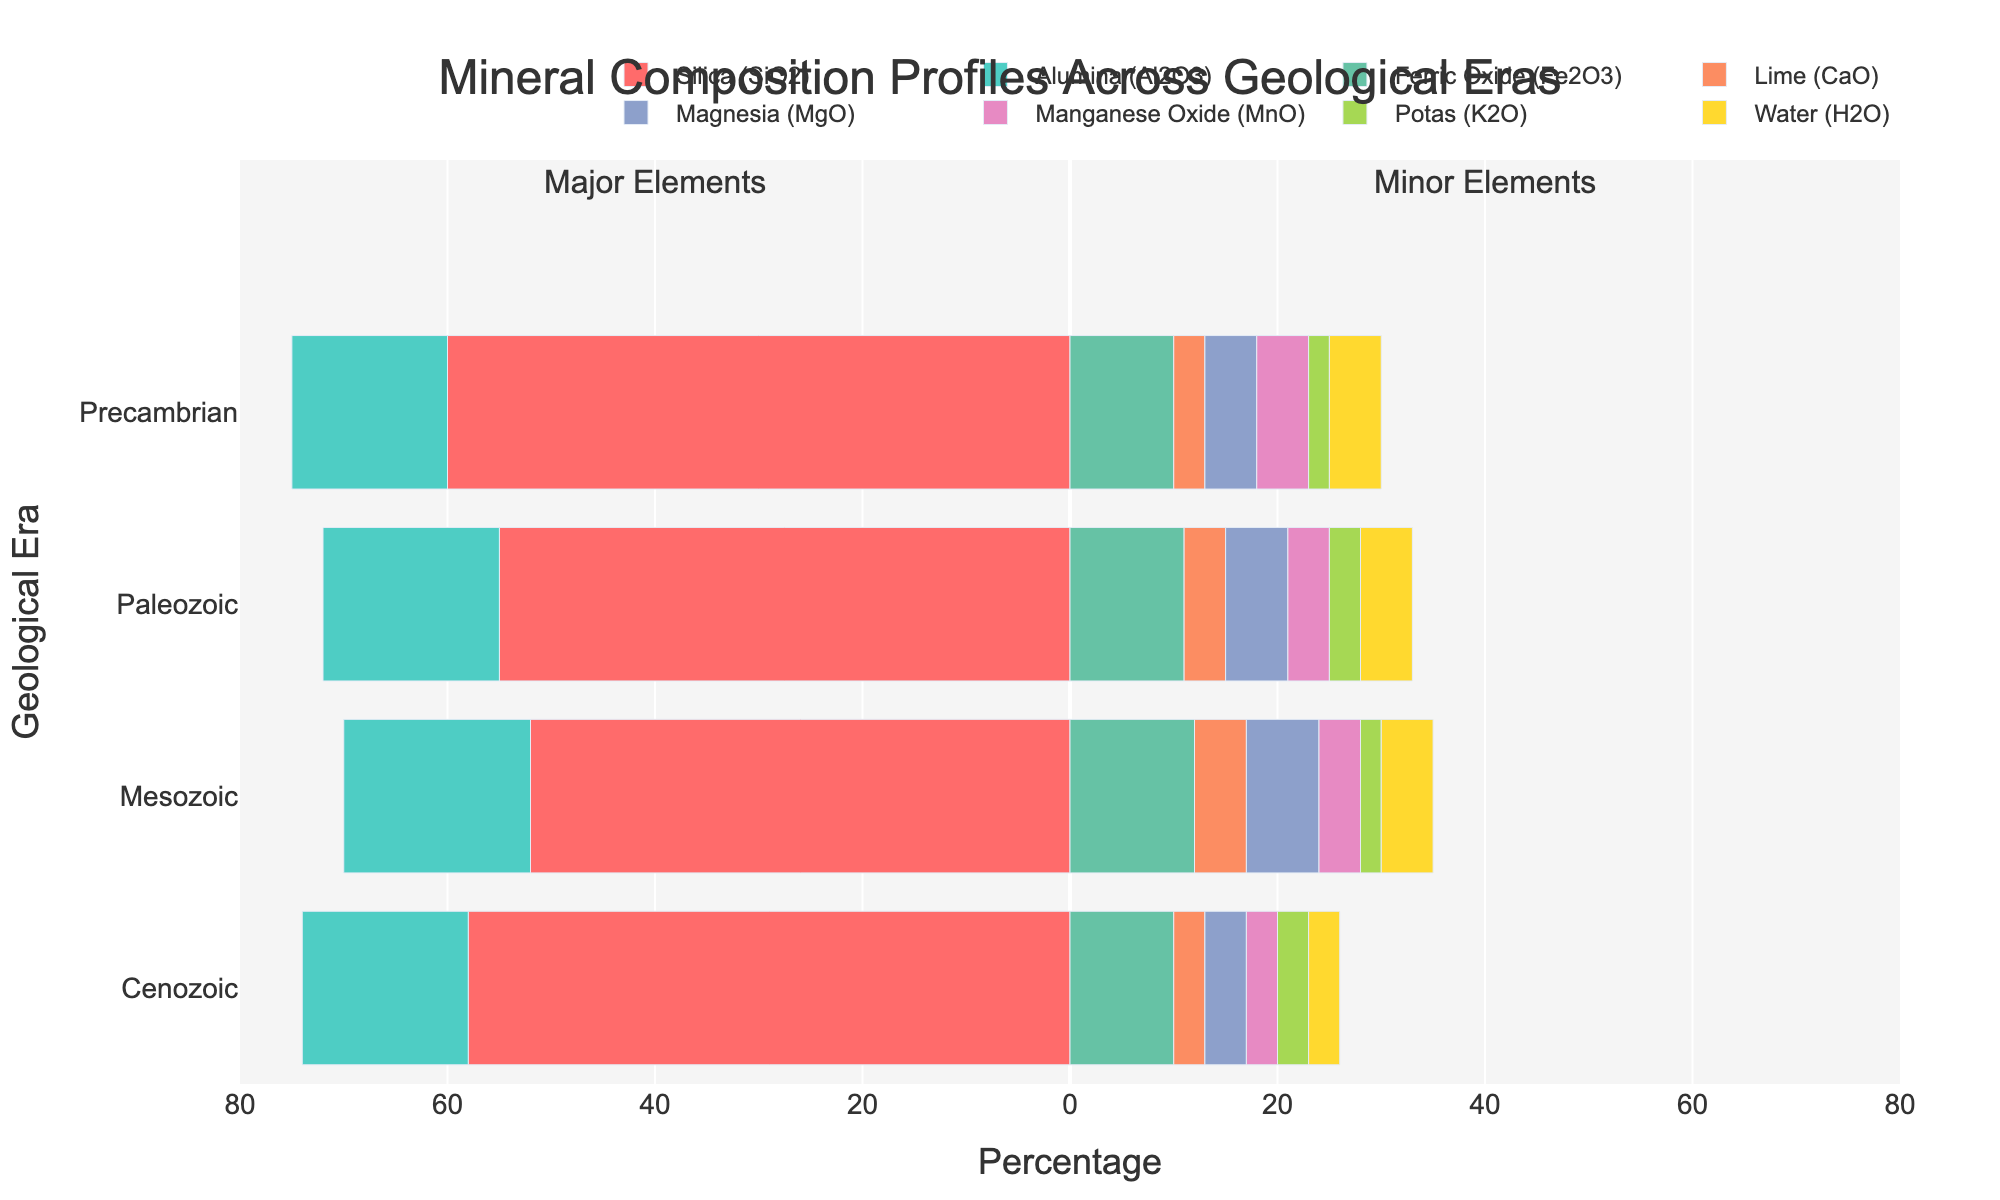What is the total percentage of major elements in the Precambrian era? To find the total percentage of major elements in the Precambrian era, sum the percentages of Silica (SiO2) and Alumina (Al2O3): 60 + 15 = 75
Answer: 75 Which era has the highest percentage of Silica (SiO2)? Compare the percentages of Silica (SiO2) across all eras: Precambrian (60%), Paleozoic (55%), Mesozoic (52%), Cenozoic (58%). The highest is in the Precambrian.
Answer: Precambrian How does the percentage of Ferric Oxide (Fe2O3) in the Paleozoic era compare to the Mesozoic era? The percentage of Ferric Oxide in the Paleozoic era is 11% and in the Mesozoic era is 12%. 11% is less than 12%.
Answer: Less than What is the sum of minor elements in the Cenozoic era? Sum the percentages of all minor elements in the Cenozoic era: Ferric Oxide (10) + Magnesia (4) + Lime (3) + Potas (3) + Manganese Oxide (3) + Water (3) = 26
Answer: 26 Which major element is more abundant in the Precambrian era, Silica (SiO2) or Alumina (Al2O3)? Compare the percentages of Silica (60%) and Alumina (15%) in the Precambrian era. Silica is more abundant.
Answer: Silica (SiO2) In which era is the percentage of Alumina (Al2O3) the lowest? Compare the percentages of Alumina (Al2O3) across all eras: Precambrian (15%), Paleozoic (17%), Mesozoic (18%), Cenozoic (16%). The lowest is in the Precambrian.
Answer: Precambrian What is the difference in the percentage of Magnesia (MgO) between the Mesozoic and Cenozoic eras? Calculate the difference in Magnesia (MgO) percentage: Mesozoic (7%) - Cenozoic (4%) = 3
Answer: 3 How does the percentage of Lime (CaO) in the Paleozoic era compare with the Mesozoic era visually? Visually compare the lengths of the bars representing Lime (CaO) in the Paleozoic (4%) and Mesozoic (5%). The bar is slightly shorter in the Paleozoic era.
Answer: Shorter Across how many eras does the percentage of Water (H2O) remain constant? Observe the percentage of Water (H2O) for all eras: Precambrian (5%), Paleozoic (5%), Mesozoic (5%), Cenozoic (3%). Water percentage remains constant in three eras (Precambrian, Paleozoic, Mesozoic).
Answer: Three What is the maximum percentage of any single minor element across all eras? Scan all minor elements in each era and identify the highest percentage: Ferric Oxide (12%) in the Mesozoic and Paleozoic eras.
Answer: 12 